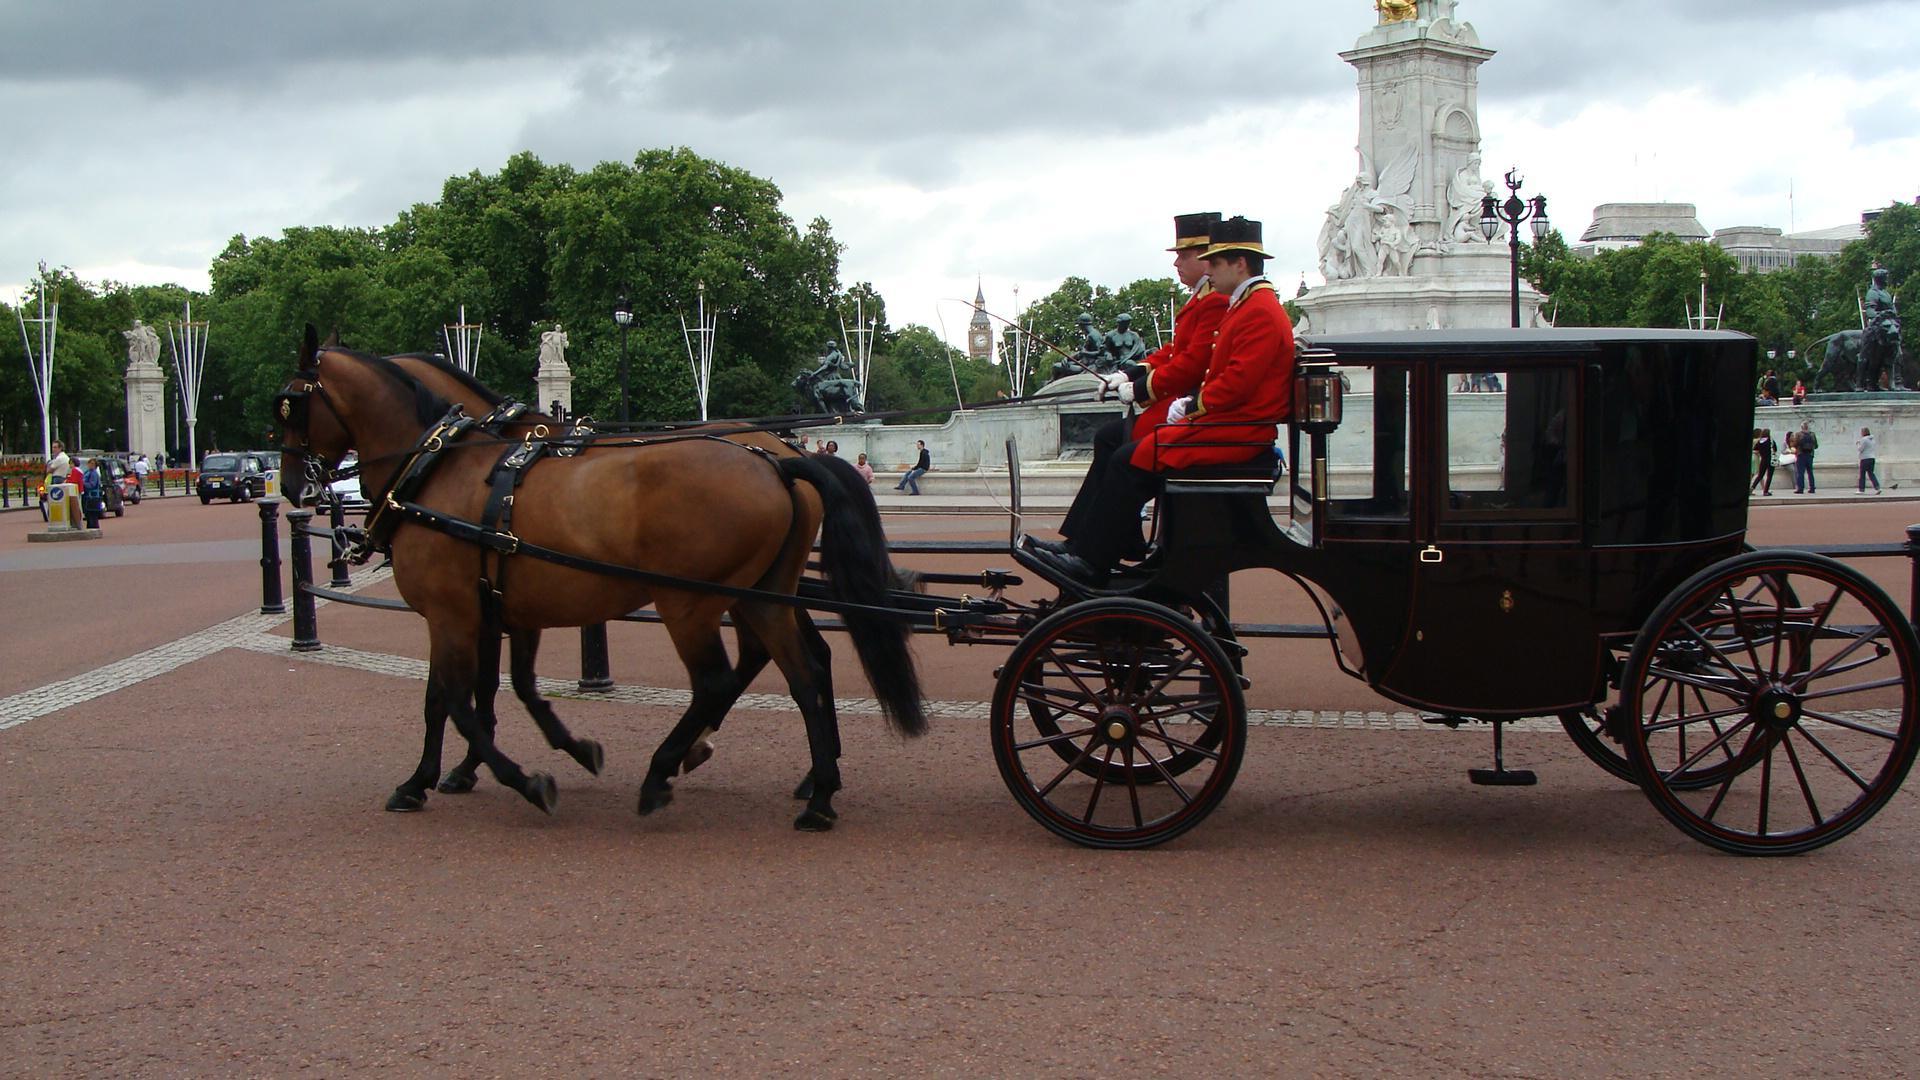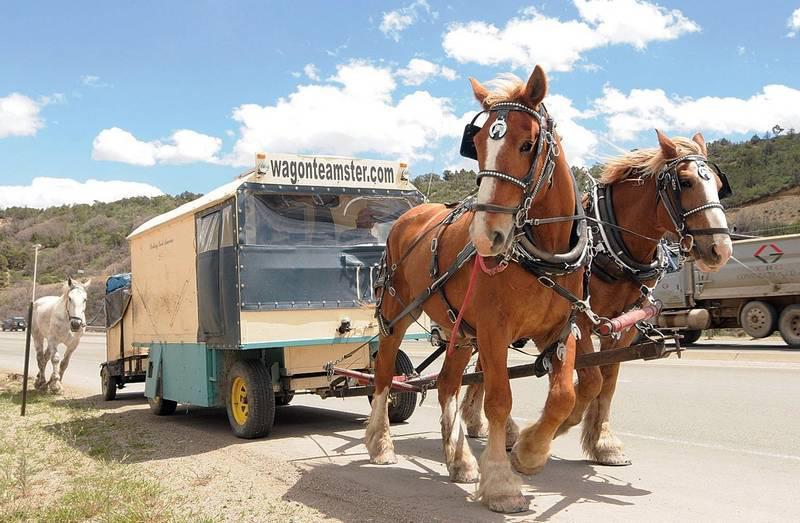The first image is the image on the left, the second image is the image on the right. Given the left and right images, does the statement "An image shows a wagon carrying at least one wooden barrel." hold true? Answer yes or no. No. 